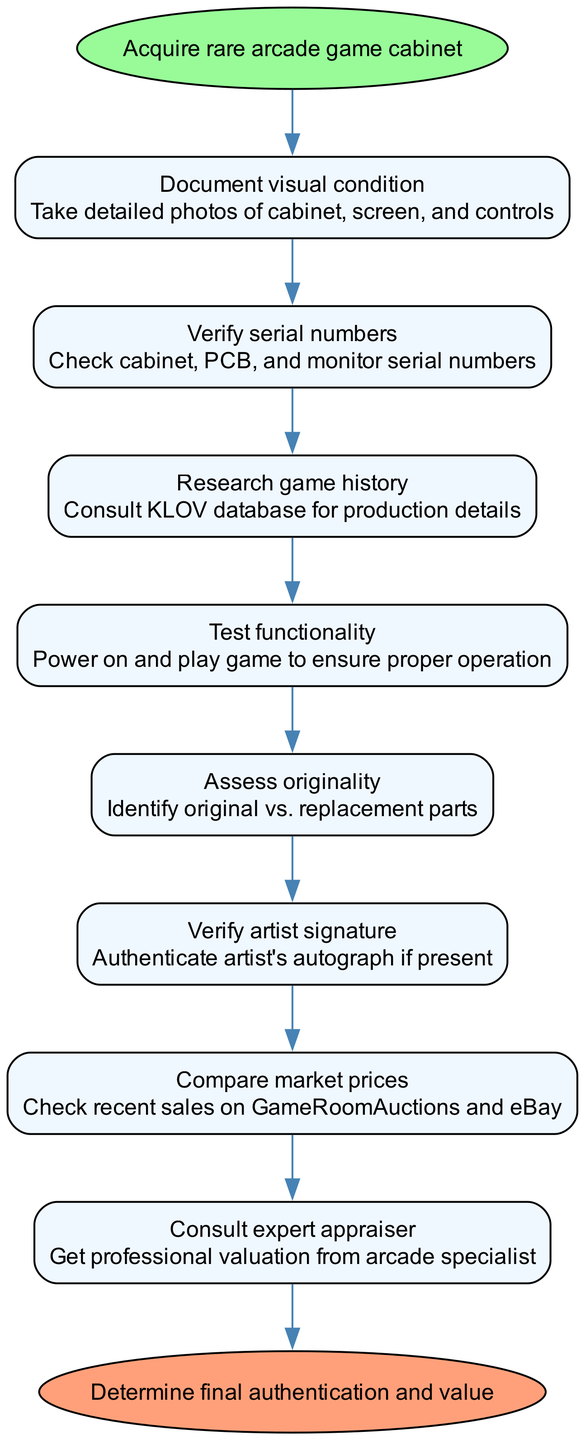What is the first step in the diagram? The first step is indicated as the initial node that follows the "start" node. According to the flow chart, it states "Document visual condition," which means taking detailed photos of the cabinet, screen, and controls. Therefore, the first step is to document the visual condition.
Answer: Document visual condition How many total steps are shown in the diagram? To find the total number of steps, we can count the nodes that represent specific steps between the "start" and "end" nodes. There are eight steps in total listed in the diagram.
Answer: Eight What condition must be documented first when acquiring a rare arcade game? The diagram clearly states that the visual condition must be documented first. It specifically points out the need to take detailed photos of the cabinet, screen, and controls.
Answer: Document visual condition What does the step after verifying serial numbers involve? This requires examining the flow of the steps. After verifying serial numbers, the next step is to research the game history according to the multitude of steps presented.
Answer: Research game history How does one authenticate the artist's autograph if present? This is specified as a direct action in the steps of the process, which states to verify the artist signature. Where this step is mentioned in the flow chart, it emphasizes the need for authentication if an autograph is present.
Answer: Verify artist signature What should be consulted for game production details? The diagram indicates that one should consult the KLOV database in the step following "Verify serial numbers." This database will provide the needed production details for the arcade game.
Answer: KLOV database Which step assesses the originality of the arcade game's parts? In the diagram, the step that specifically addresses the assessment of originality is stated directly as "Assess originality," where the task is to identify original versus replacement parts.
Answer: Assess originality What action needs to happen before consulting an expert appraiser? To understand the necessary sequence, we observe that the step before consulting an expert appraiser is to compare market prices. Therefore, the action necessary before consulting an expert is to compare recent sales prices.
Answer: Compare market prices 